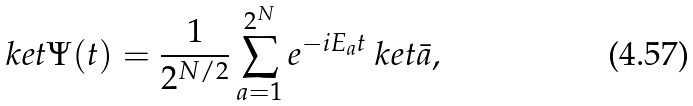Convert formula to latex. <formula><loc_0><loc_0><loc_500><loc_500>\ k e t { \Psi ( t ) } = \frac { 1 } { 2 ^ { N / 2 } } \sum _ { a = 1 } ^ { 2 ^ { N } } e ^ { - i E _ { a } t } \ k e t { \bar { a } } ,</formula> 